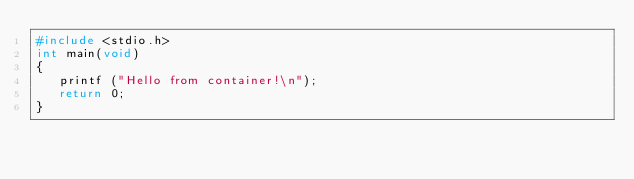Convert code to text. <code><loc_0><loc_0><loc_500><loc_500><_C_>#include <stdio.h>
int main(void)
{
   printf ("Hello from container!\n");
   return 0;
}
</code> 